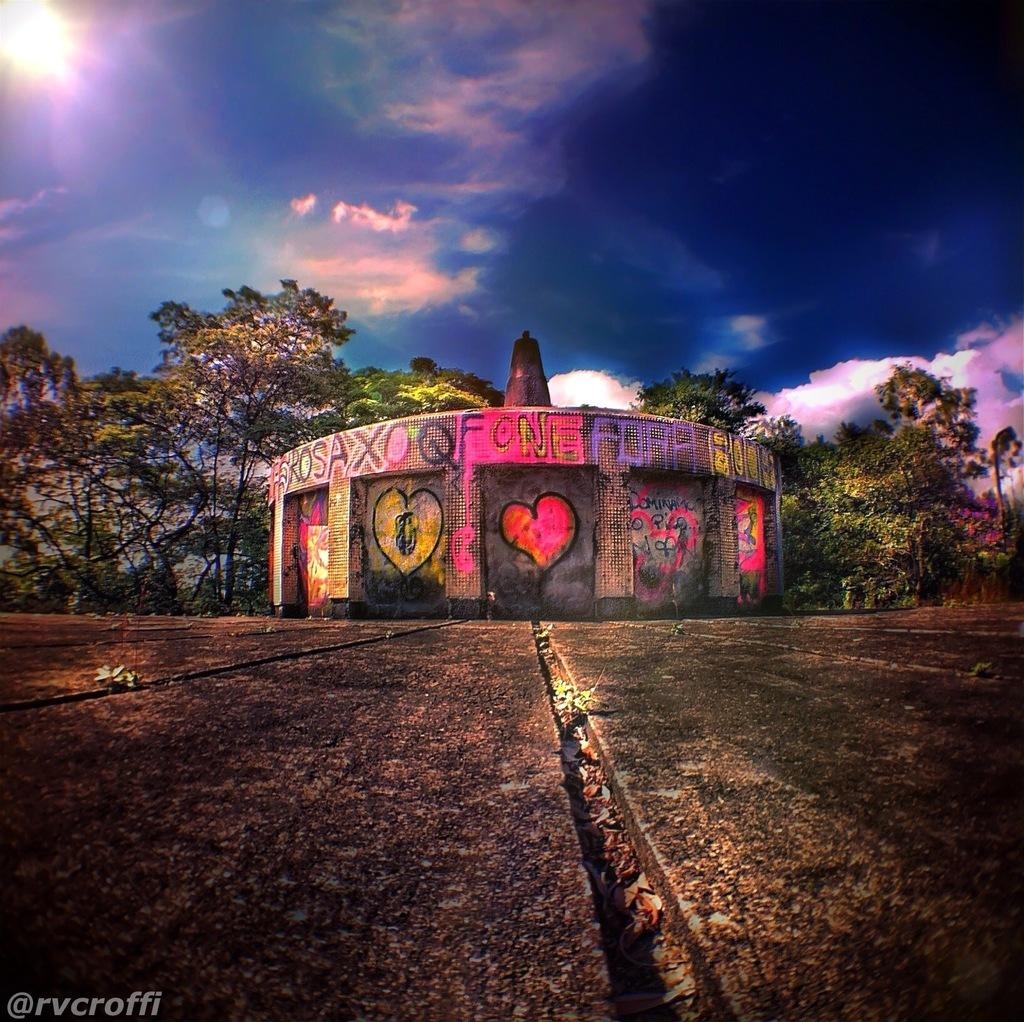What is on the wall in the image? There is graffiti on a wall in the image. What else can be seen in the bottom left of the image? There is some text visible in the bottom left of the image. What type of vegetation is in the background of the image? There are trees in the background of the image. How would you describe the sky in the image? The sky is blue and cloudy in the image. What type of game is being played in the image? There is no game being played in the image; it features graffiti on a wall, text, trees, and a blue and cloudy sky. 